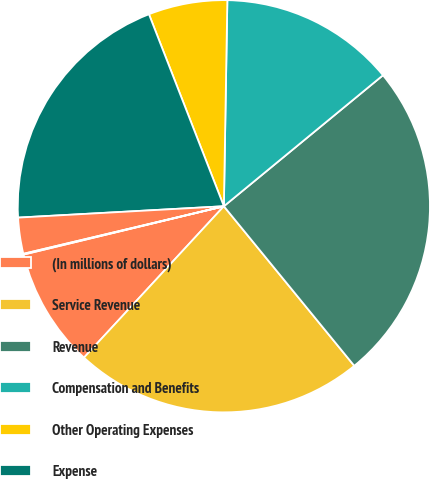Convert chart. <chart><loc_0><loc_0><loc_500><loc_500><pie_chart><fcel>(In millions of dollars)<fcel>Service Revenue<fcel>Revenue<fcel>Compensation and Benefits<fcel>Other Operating Expenses<fcel>Expense<fcel>Operating Income<fcel>Operating Margin<nl><fcel>9.36%<fcel>22.78%<fcel>25.06%<fcel>13.77%<fcel>6.19%<fcel>19.96%<fcel>2.83%<fcel>0.06%<nl></chart> 